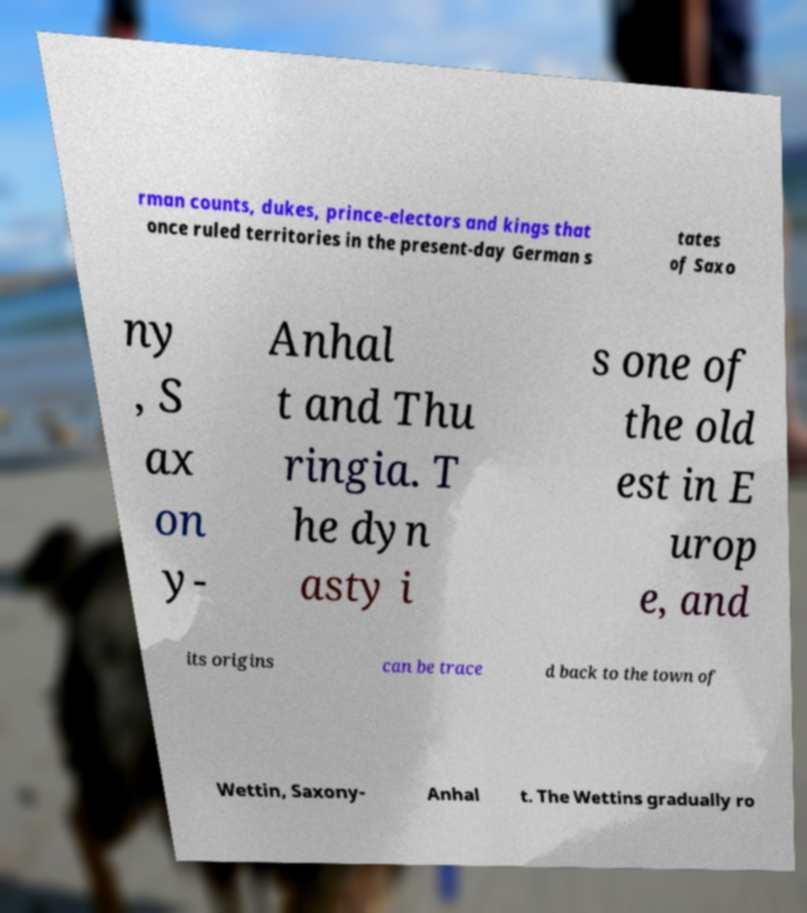For documentation purposes, I need the text within this image transcribed. Could you provide that? rman counts, dukes, prince-electors and kings that once ruled territories in the present-day German s tates of Saxo ny , S ax on y- Anhal t and Thu ringia. T he dyn asty i s one of the old est in E urop e, and its origins can be trace d back to the town of Wettin, Saxony- Anhal t. The Wettins gradually ro 